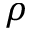Convert formula to latex. <formula><loc_0><loc_0><loc_500><loc_500>\rho</formula> 